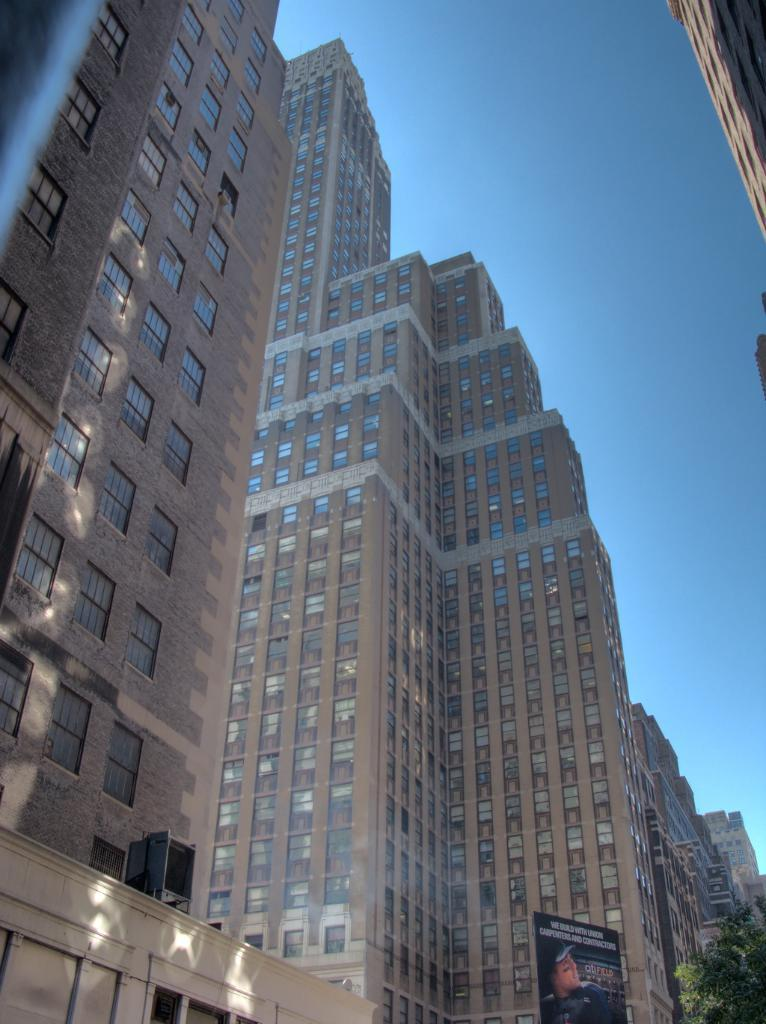What type of structures are visible in the image? There are many buildings with windows in the image. Are there any specific features of the buildings? Some of the buildings have glass walls. What can be seen in the right bottom corner of the image? There is a banner and a tree in the right bottom corner of the image. What is visible in the background of the image? The sky is visible in the background of the image. What type of crime is being committed in the image? There is no indication of any crime being committed in the image. What is the reaction of the donkey in the image? There are no donkeys present in the image. 